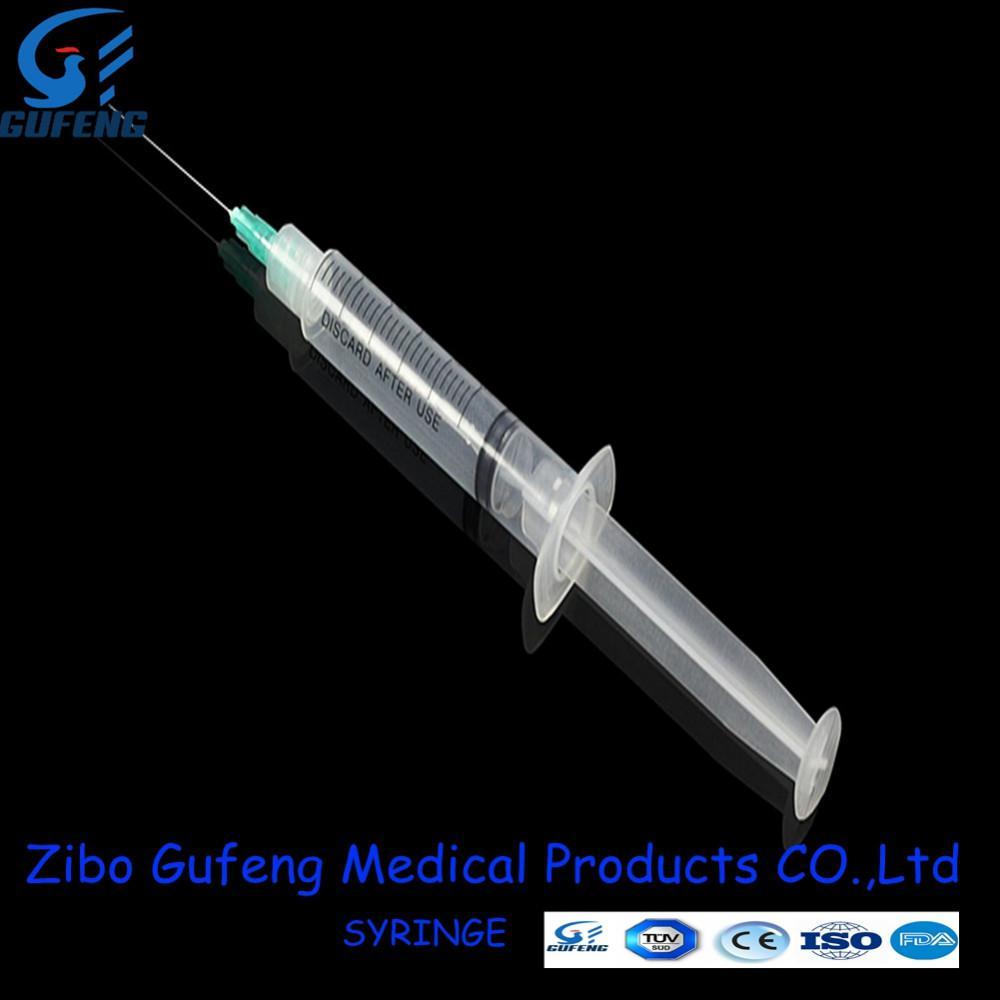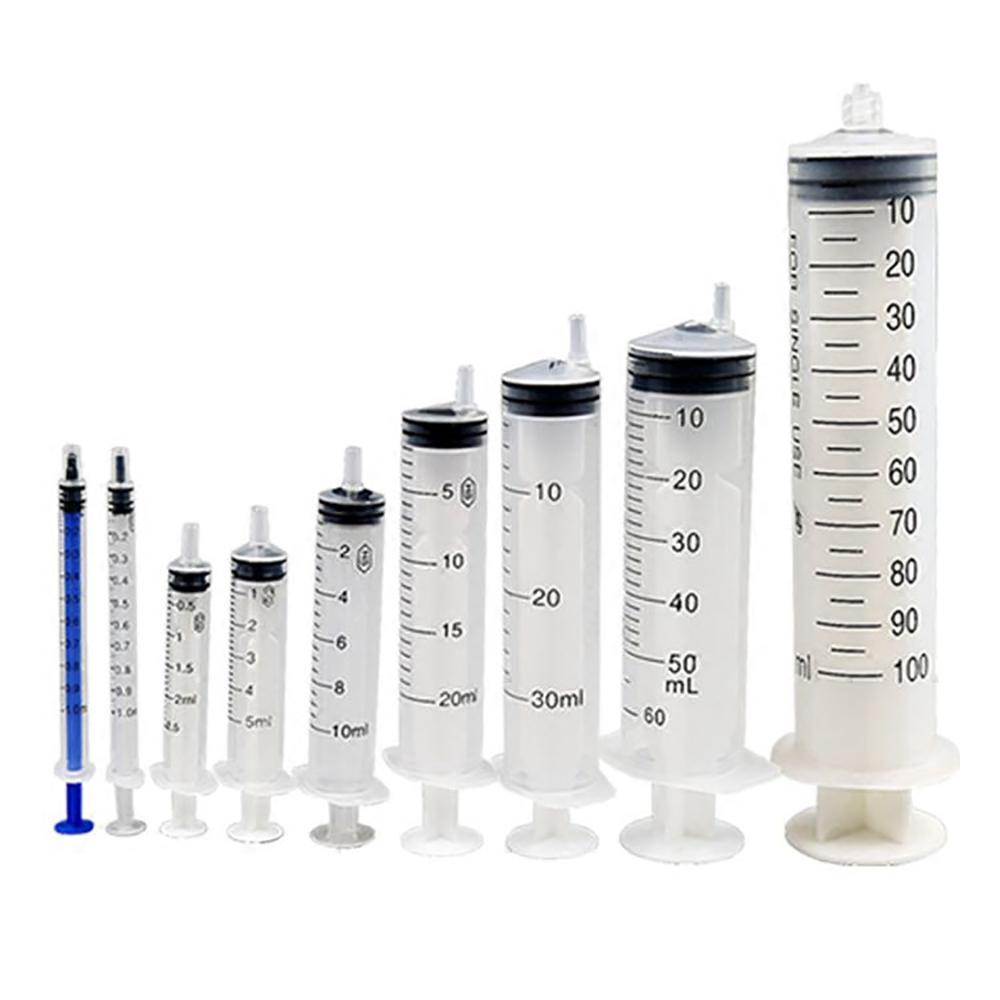The first image is the image on the left, the second image is the image on the right. Evaluate the accuracy of this statement regarding the images: "The left image shows a single syringe with needle attached.". Is it true? Answer yes or no. Yes. The first image is the image on the left, the second image is the image on the right. Examine the images to the left and right. Is the description "At least one syringe needle is uncapped." accurate? Answer yes or no. Yes. 